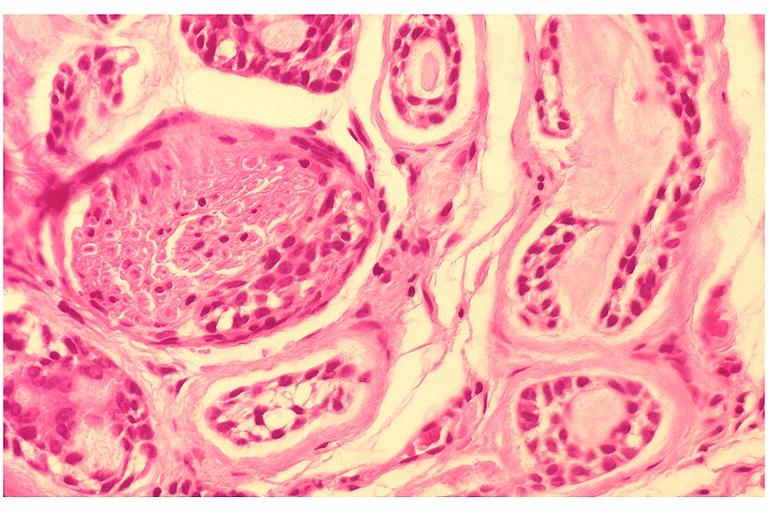does this image show adenoid cystic carcinoma?
Answer the question using a single word or phrase. Yes 